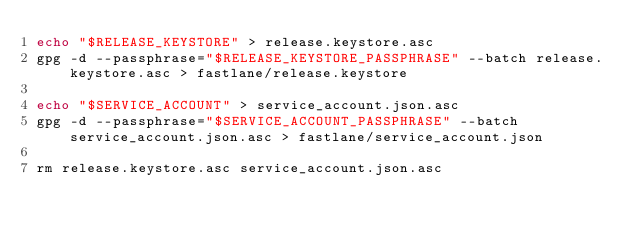Convert code to text. <code><loc_0><loc_0><loc_500><loc_500><_Bash_>echo "$RELEASE_KEYSTORE" > release.keystore.asc
gpg -d --passphrase="$RELEASE_KEYSTORE_PASSPHRASE" --batch release.keystore.asc > fastlane/release.keystore

echo "$SERVICE_ACCOUNT" > service_account.json.asc
gpg -d --passphrase="$SERVICE_ACCOUNT_PASSPHRASE" --batch service_account.json.asc > fastlane/service_account.json

rm release.keystore.asc service_account.json.asc
</code> 